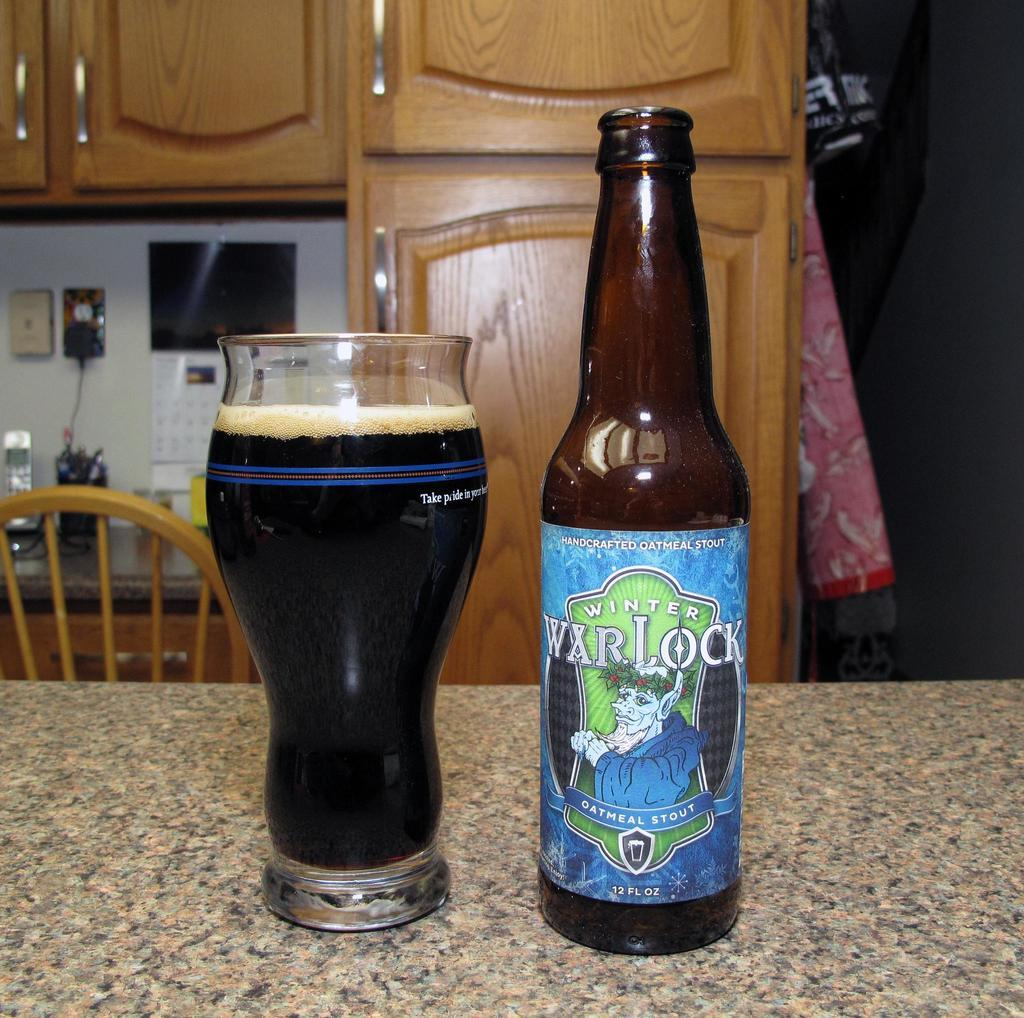<image>
Create a compact narrative representing the image presented. Bottle of Winter Warlock with a blue label next to a tall glass of beer. 